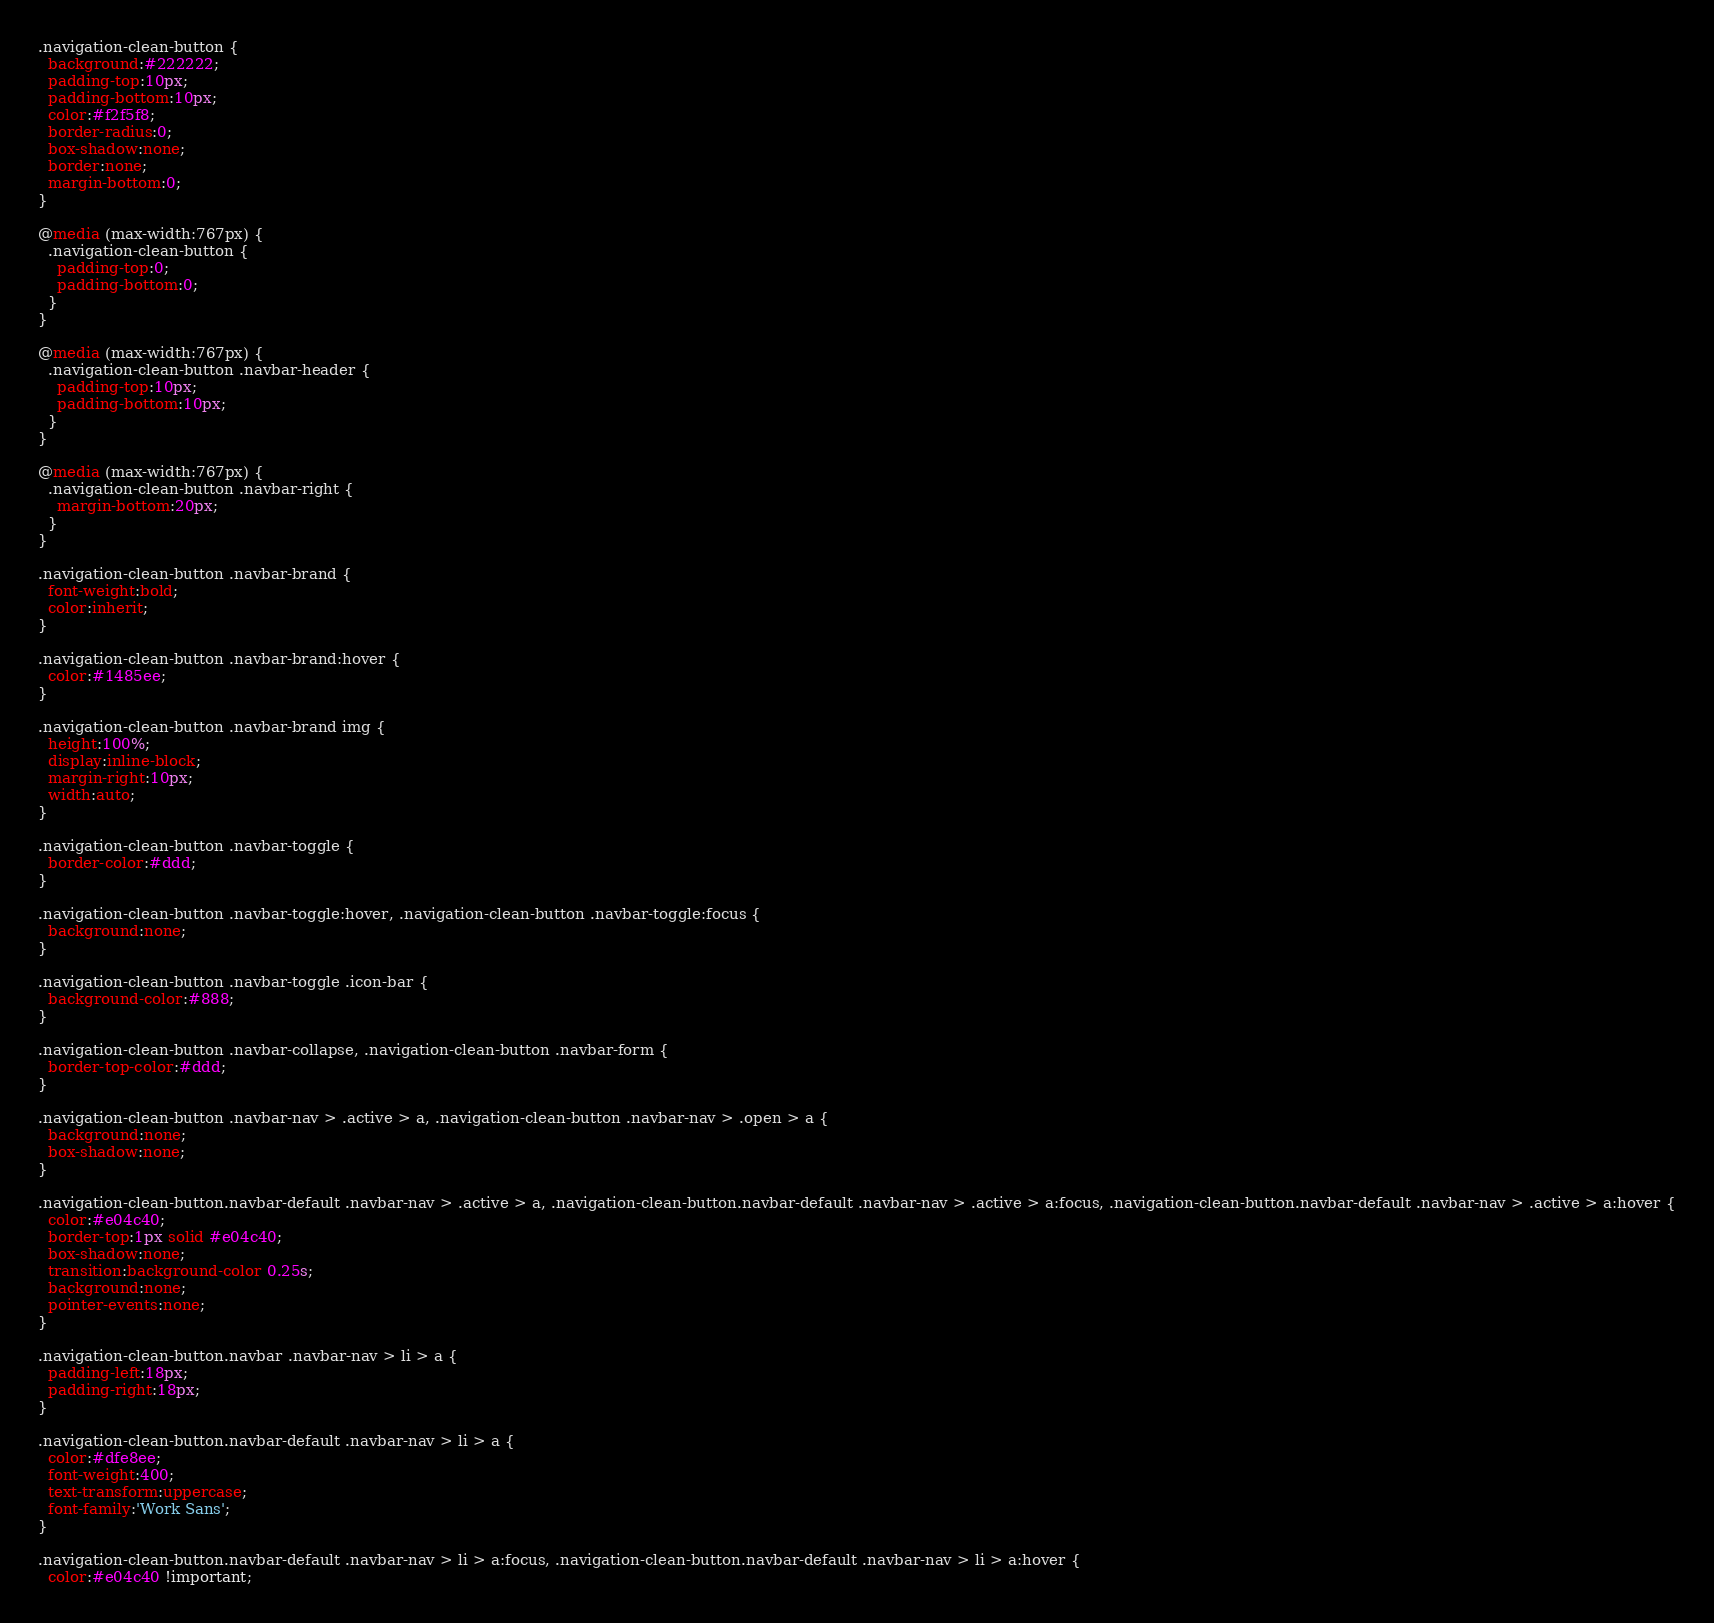<code> <loc_0><loc_0><loc_500><loc_500><_CSS_>.navigation-clean-button {
  background:#222222;
  padding-top:10px;
  padding-bottom:10px;
  color:#f2f5f8;
  border-radius:0;
  box-shadow:none;
  border:none;
  margin-bottom:0;
}

@media (max-width:767px) {
  .navigation-clean-button {
    padding-top:0;
    padding-bottom:0;
  }
}

@media (max-width:767px) {
  .navigation-clean-button .navbar-header {
    padding-top:10px;
    padding-bottom:10px;
  }
}

@media (max-width:767px) {
  .navigation-clean-button .navbar-right {
    margin-bottom:20px;
  }
}

.navigation-clean-button .navbar-brand {
  font-weight:bold;
  color:inherit;
}

.navigation-clean-button .navbar-brand:hover {
  color:#1485ee;
}

.navigation-clean-button .navbar-brand img {
  height:100%;
  display:inline-block;
  margin-right:10px;
  width:auto;
}

.navigation-clean-button .navbar-toggle {
  border-color:#ddd;
}

.navigation-clean-button .navbar-toggle:hover, .navigation-clean-button .navbar-toggle:focus {
  background:none;
}

.navigation-clean-button .navbar-toggle .icon-bar {
  background-color:#888;
}

.navigation-clean-button .navbar-collapse, .navigation-clean-button .navbar-form {
  border-top-color:#ddd;
}

.navigation-clean-button .navbar-nav > .active > a, .navigation-clean-button .navbar-nav > .open > a {
  background:none;
  box-shadow:none;
}

.navigation-clean-button.navbar-default .navbar-nav > .active > a, .navigation-clean-button.navbar-default .navbar-nav > .active > a:focus, .navigation-clean-button.navbar-default .navbar-nav > .active > a:hover {
  color:#e04c40;
  border-top:1px solid #e04c40;
  box-shadow:none;
  transition:background-color 0.25s;
  background:none;
  pointer-events:none;
}

.navigation-clean-button.navbar .navbar-nav > li > a {
  padding-left:18px;
  padding-right:18px;
}

.navigation-clean-button.navbar-default .navbar-nav > li > a {
  color:#dfe8ee;
  font-weight:400;
  text-transform:uppercase;
  font-family:'Work Sans';
}

.navigation-clean-button.navbar-default .navbar-nav > li > a:focus, .navigation-clean-button.navbar-default .navbar-nav > li > a:hover {
  color:#e04c40 !important;</code> 